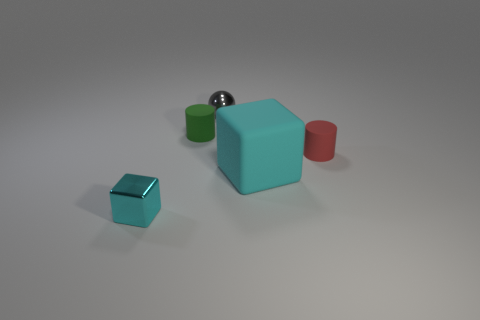Could you describe the lighting and how it affects the appearance of the objects? The lighting in the image appears to be soft and diffused, coming from a direction that casts subtle shadows towards the front-right side of the objects. This kind of lighting minimizes harsh reflections and allows the colors and textures of the objects to be seen clearly. It creates a calm and balanced composition, highlighting the forms of the objects without causing overexposure or distracting glare. 